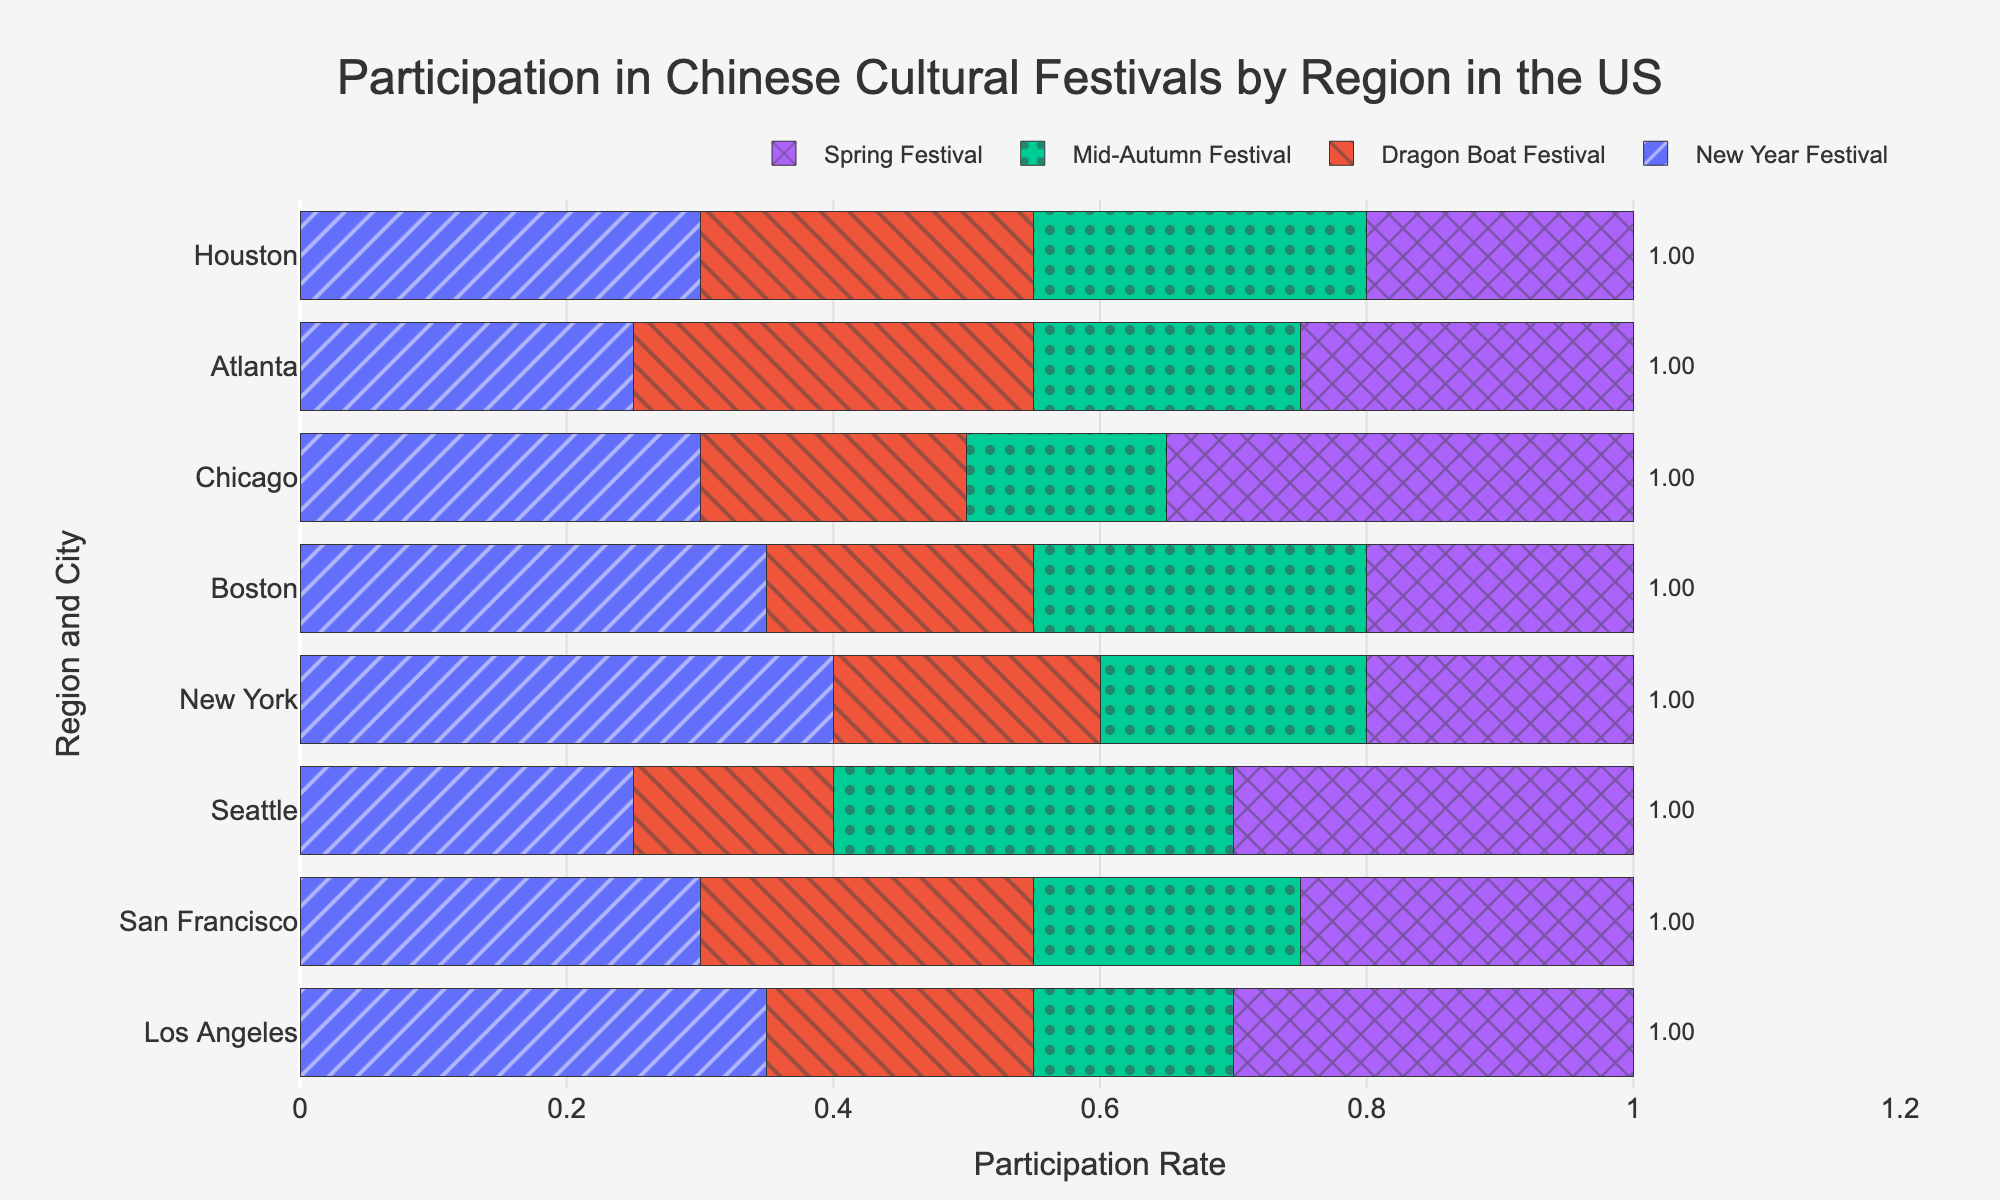Which city on the East Coast has the highest participation rate in the New Year Festival? Look for the bars representing participation in the New Year Festival on the East Coast cities. New York has a higher bar compared to Boston.
Answer: New York Which region has the highest total participation rate across all festivals? Sum the participation rates for all festivals in each region. Compare the totals; the West Coast cities have the highest sums.
Answer: West Coast In which city is the participation in the Dragon Boat Festival more than the Spring Festival? Look at the bars representing the Dragon Boat Festival and Spring Festival for each city. In Atlanta, the participation for the Dragon Boat Festival (0.30) is more than the Spring Festival (0.25).
Answer: Atlanta What is the participation rate difference between New York and Houston for the Spring Festival? Locate the Spring Festival bars for New York and Houston, then subtract their participation rates. New York has 0.20, and Houston has 0.20. 0.20 - 0.20 = 0.0.
Answer: 0.0 Which city has the lowest participation rate for the Mid-Autumn Festival? Compare the heights of the Mid-Autumn Festival bars. Los Angeles has the lowest bar at 0.15.
Answer: Los Angeles How similar are the participation rates for the New Year Festival in Los Angeles and Chicago? Check the heights of the New Year Festival bars for both cities. Los Angeles has 0.35, and Chicago has 0.30. The difference is 0.05 which is relatively small.
Answer: Relatively similar What is the total participation rate in San Francisco for all festivals combined? Sum the participation rates for all four festivals in San Francisco. 0.30 (New Year) + 0.25 (Dragon Boat) + 0.20 (Mid-Autumn) + 0.25 (Spring) = 1.00.
Answer: 1.00 Do any cities in the Midwest show a higher participation rate for the New Year Festival compared to the Dragon Boat Festival? Compare the participation bars for the New Year and Dragon Boat festivals in Midwest cities. In Chicago, the New Year Festival (0.30) is higher than the Dragon Boat Festival (0.20).
Answer: Chicago Which festival has the most consistent participation rate across all the cities? Compare the visual heights of the bars for each festival across all cities. The Spring Festival bars seem to be the most consistently similar in height.
Answer: Spring Festival How does the participation rate for the Mid-Autumn Festival in Seattle compare to that in Boston? Check the Mid-Autumn Festival bars for Seattle and Boston. Seattle has a participation rate of 0.30, and Boston has 0.25. Seattle has a higher rate by 0.05.
Answer: Seattle 